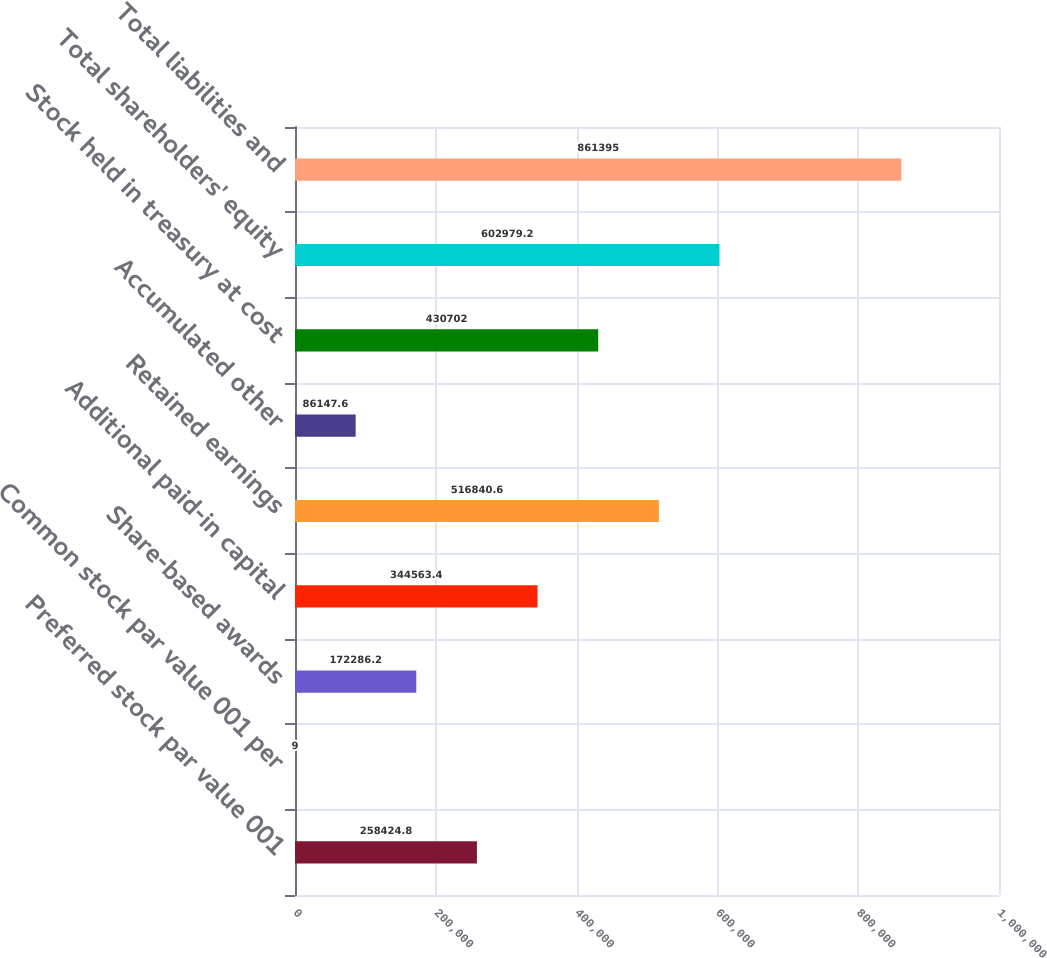Convert chart to OTSL. <chart><loc_0><loc_0><loc_500><loc_500><bar_chart><fcel>Preferred stock par value 001<fcel>Common stock par value 001 per<fcel>Share-based awards<fcel>Additional paid-in capital<fcel>Retained earnings<fcel>Accumulated other<fcel>Stock held in treasury at cost<fcel>Total shareholders' equity<fcel>Total liabilities and<nl><fcel>258425<fcel>9<fcel>172286<fcel>344563<fcel>516841<fcel>86147.6<fcel>430702<fcel>602979<fcel>861395<nl></chart> 